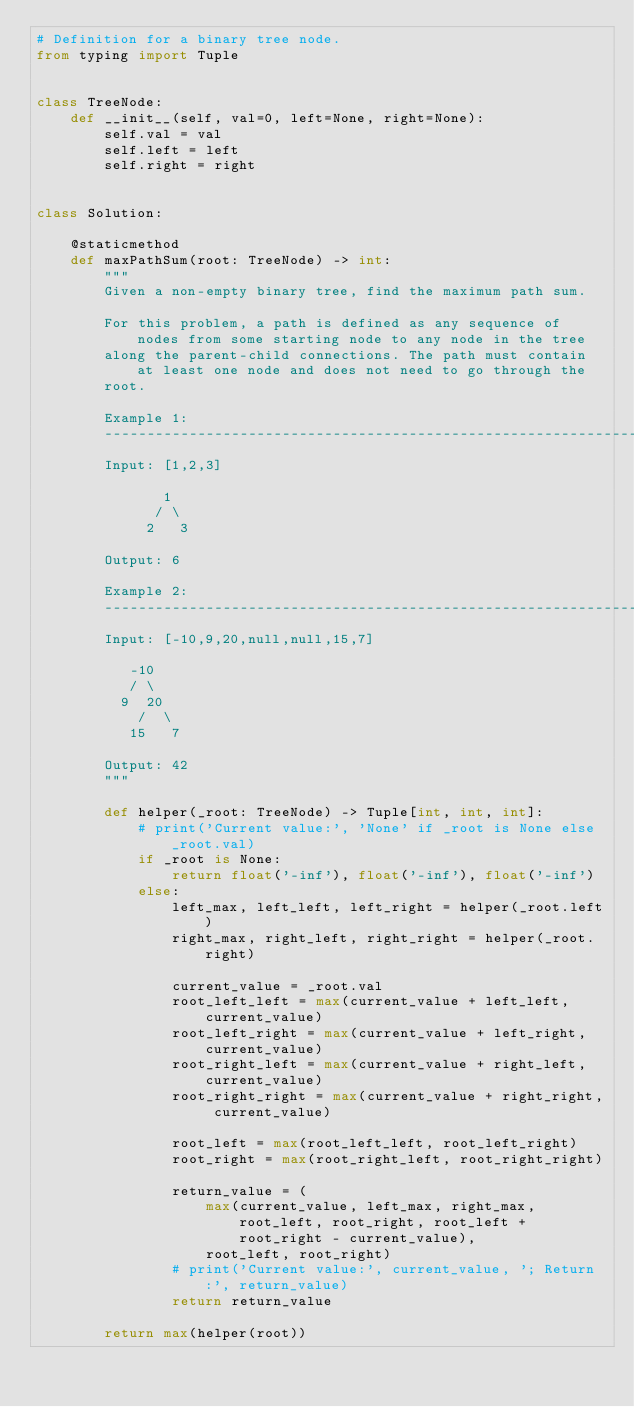<code> <loc_0><loc_0><loc_500><loc_500><_Python_># Definition for a binary tree node.
from typing import Tuple


class TreeNode:
    def __init__(self, val=0, left=None, right=None):
        self.val = val
        self.left = left
        self.right = right


class Solution:

    @staticmethod
    def maxPathSum(root: TreeNode) -> int:
        """
        Given a non-empty binary tree, find the maximum path sum.

        For this problem, a path is defined as any sequence of nodes from some starting node to any node in the tree
        along the parent-child connections. The path must contain at least one node and does not need to go through the
        root.

        Example 1:
        ----------------------------------------------------------------------------------------------------------------
        Input: [1,2,3]

               1
              / \
             2   3

        Output: 6

        Example 2:
        ----------------------------------------------------------------------------------------------------------------
        Input: [-10,9,20,null,null,15,7]

           -10
           / \
          9  20
            /  \
           15   7

        Output: 42
        """

        def helper(_root: TreeNode) -> Tuple[int, int, int]:
            # print('Current value:', 'None' if _root is None else _root.val)
            if _root is None:
                return float('-inf'), float('-inf'), float('-inf')
            else:
                left_max, left_left, left_right = helper(_root.left)
                right_max, right_left, right_right = helper(_root.right)

                current_value = _root.val
                root_left_left = max(current_value + left_left, current_value)
                root_left_right = max(current_value + left_right, current_value)
                root_right_left = max(current_value + right_left, current_value)
                root_right_right = max(current_value + right_right, current_value)

                root_left = max(root_left_left, root_left_right)
                root_right = max(root_right_left, root_right_right)

                return_value = (
                    max(current_value, left_max, right_max, root_left, root_right, root_left + root_right - current_value),
                    root_left, root_right)
                # print('Current value:', current_value, '; Return:', return_value)
                return return_value

        return max(helper(root))
</code> 